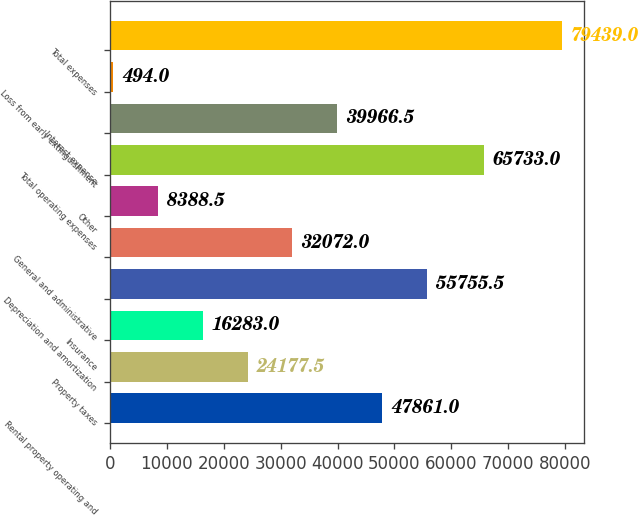Convert chart to OTSL. <chart><loc_0><loc_0><loc_500><loc_500><bar_chart><fcel>Rental property operating and<fcel>Property taxes<fcel>Insurance<fcel>Depreciation and amortization<fcel>General and administrative<fcel>Other<fcel>Total operating expenses<fcel>Interest expense<fcel>Loss from early extinguishment<fcel>Total expenses<nl><fcel>47861<fcel>24177.5<fcel>16283<fcel>55755.5<fcel>32072<fcel>8388.5<fcel>65733<fcel>39966.5<fcel>494<fcel>79439<nl></chart> 